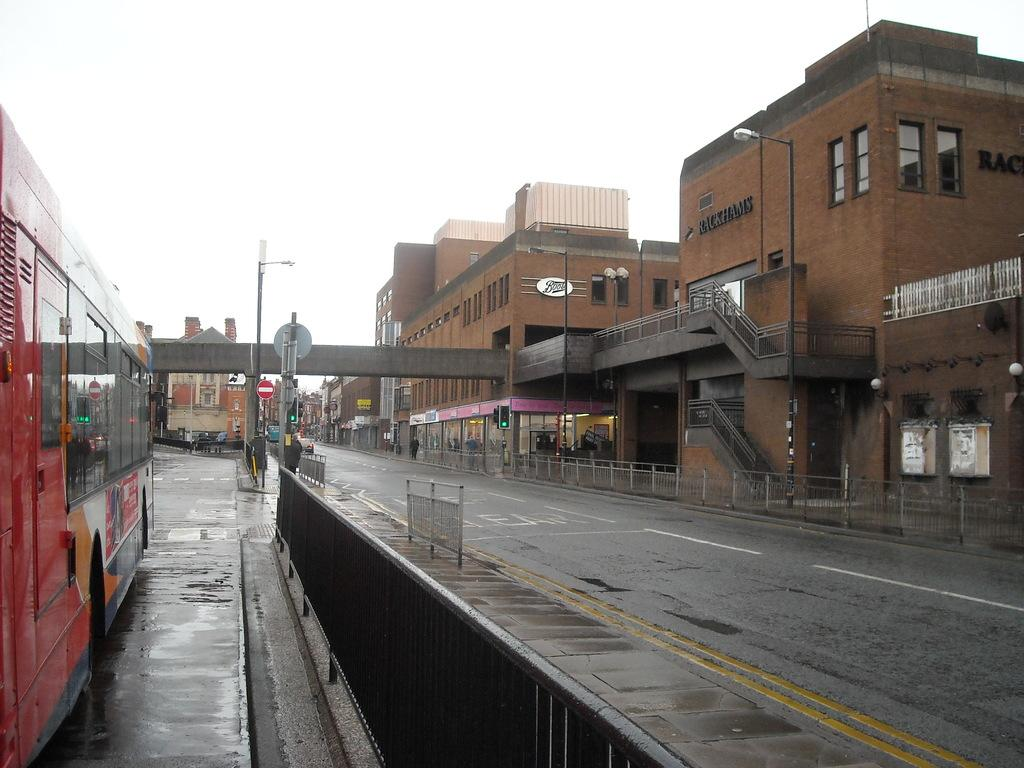Provide a one-sentence caption for the provided image. an almost empty street next to a Rackham's building. 